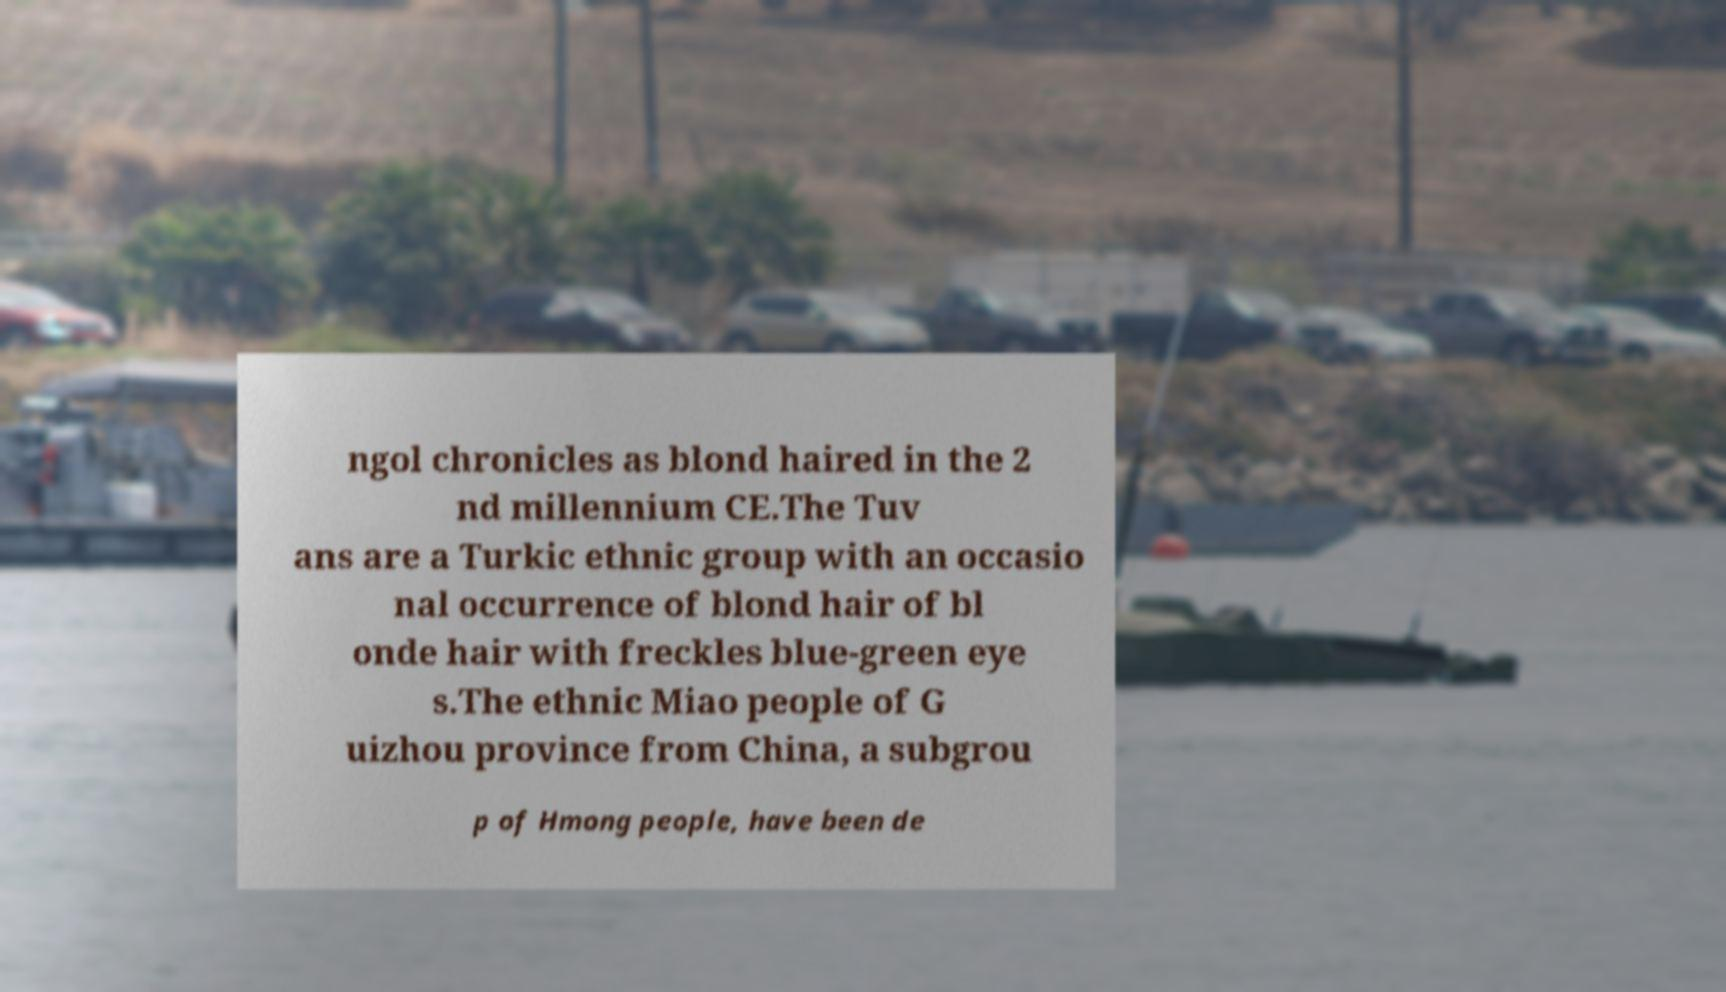There's text embedded in this image that I need extracted. Can you transcribe it verbatim? ngol chronicles as blond haired in the 2 nd millennium CE.The Tuv ans are a Turkic ethnic group with an occasio nal occurrence of blond hair of bl onde hair with freckles blue-green eye s.The ethnic Miao people of G uizhou province from China, a subgrou p of Hmong people, have been de 